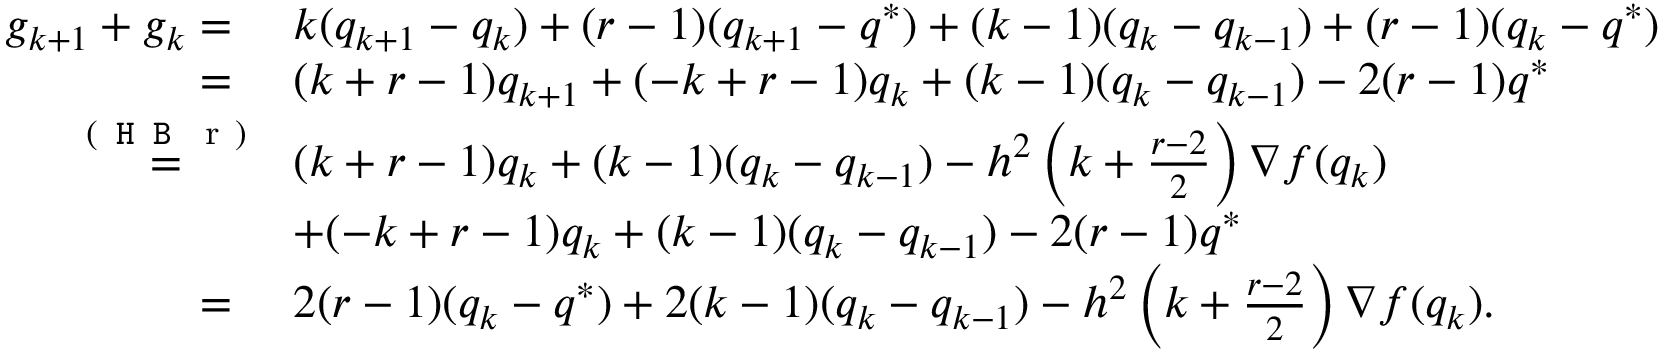Convert formula to latex. <formula><loc_0><loc_0><loc_500><loc_500>\begin{array} { r l } { g _ { k + 1 } + g _ { k } = \ } & { k ( q _ { k + 1 } - q _ { k } ) + ( r - 1 ) ( q _ { k + 1 } - q ^ { * } ) + ( k - 1 ) ( q _ { k } - q _ { k - 1 } ) + ( r - 1 ) ( q _ { k } - q ^ { * } ) } \\ { = \ } & { ( k + r - 1 ) q _ { k + 1 } + ( - k + r - 1 ) q _ { k } + ( k - 1 ) ( q _ { k } - q _ { k - 1 } ) - 2 ( r - 1 ) q ^ { * } } \\ { \overset { ( H B r ) } { = } } & { ( k + r - 1 ) q _ { k } + ( k - 1 ) ( q _ { k } - q _ { k - 1 } ) - h ^ { 2 } \left ( k + \frac { r - 2 } { 2 } \right ) \nabla f ( q _ { k } ) } \\ & { + ( - k + r - 1 ) q _ { k } + ( k - 1 ) ( q _ { k } - q _ { k - 1 } ) - 2 ( r - 1 ) q ^ { * } } \\ { = \ } & { 2 ( r - 1 ) ( q _ { k } - q ^ { * } ) + 2 ( k - 1 ) ( q _ { k } - q _ { k - 1 } ) - h ^ { 2 } \left ( k + \frac { r - 2 } { 2 } \right ) \nabla f ( q _ { k } ) . } \end{array}</formula> 